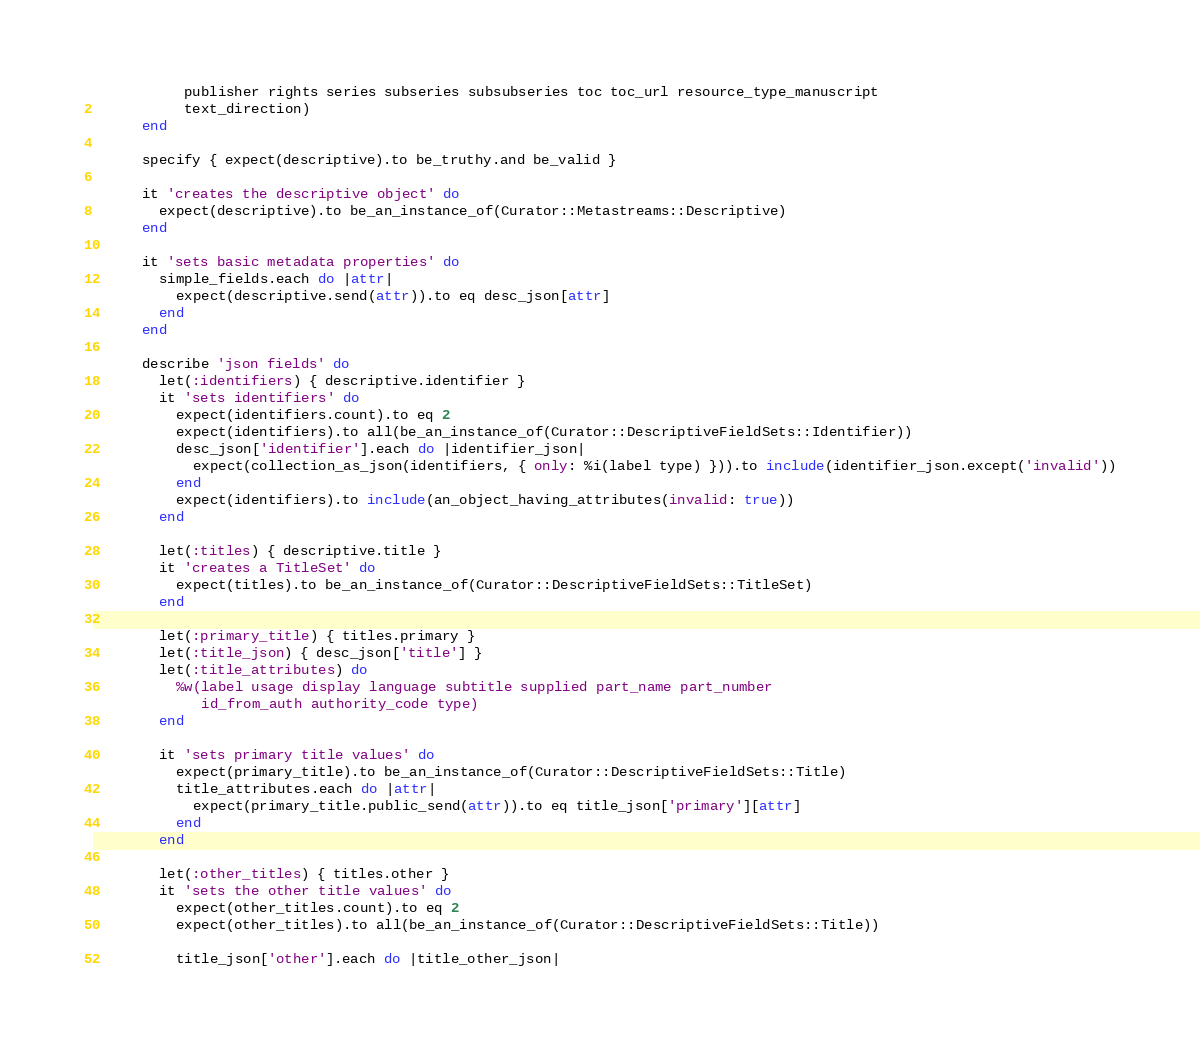Convert code to text. <code><loc_0><loc_0><loc_500><loc_500><_Ruby_>           publisher rights series subseries subsubseries toc toc_url resource_type_manuscript
           text_direction)
      end

      specify { expect(descriptive).to be_truthy.and be_valid }

      it 'creates the descriptive object' do
        expect(descriptive).to be_an_instance_of(Curator::Metastreams::Descriptive)
      end

      it 'sets basic metadata properties' do
        simple_fields.each do |attr|
          expect(descriptive.send(attr)).to eq desc_json[attr]
        end
      end

      describe 'json fields' do
        let(:identifiers) { descriptive.identifier }
        it 'sets identifiers' do
          expect(identifiers.count).to eq 2
          expect(identifiers).to all(be_an_instance_of(Curator::DescriptiveFieldSets::Identifier))
          desc_json['identifier'].each do |identifier_json|
            expect(collection_as_json(identifiers, { only: %i(label type) })).to include(identifier_json.except('invalid'))
          end
          expect(identifiers).to include(an_object_having_attributes(invalid: true))
        end

        let(:titles) { descriptive.title }
        it 'creates a TitleSet' do
          expect(titles).to be_an_instance_of(Curator::DescriptiveFieldSets::TitleSet)
        end

        let(:primary_title) { titles.primary }
        let(:title_json) { desc_json['title'] }
        let(:title_attributes) do
          %w(label usage display language subtitle supplied part_name part_number
             id_from_auth authority_code type)
        end

        it 'sets primary title values' do
          expect(primary_title).to be_an_instance_of(Curator::DescriptiveFieldSets::Title)
          title_attributes.each do |attr|
            expect(primary_title.public_send(attr)).to eq title_json['primary'][attr]
          end
        end

        let(:other_titles) { titles.other }
        it 'sets the other title values' do
          expect(other_titles.count).to eq 2
          expect(other_titles).to all(be_an_instance_of(Curator::DescriptiveFieldSets::Title))

          title_json['other'].each do |title_other_json|</code> 